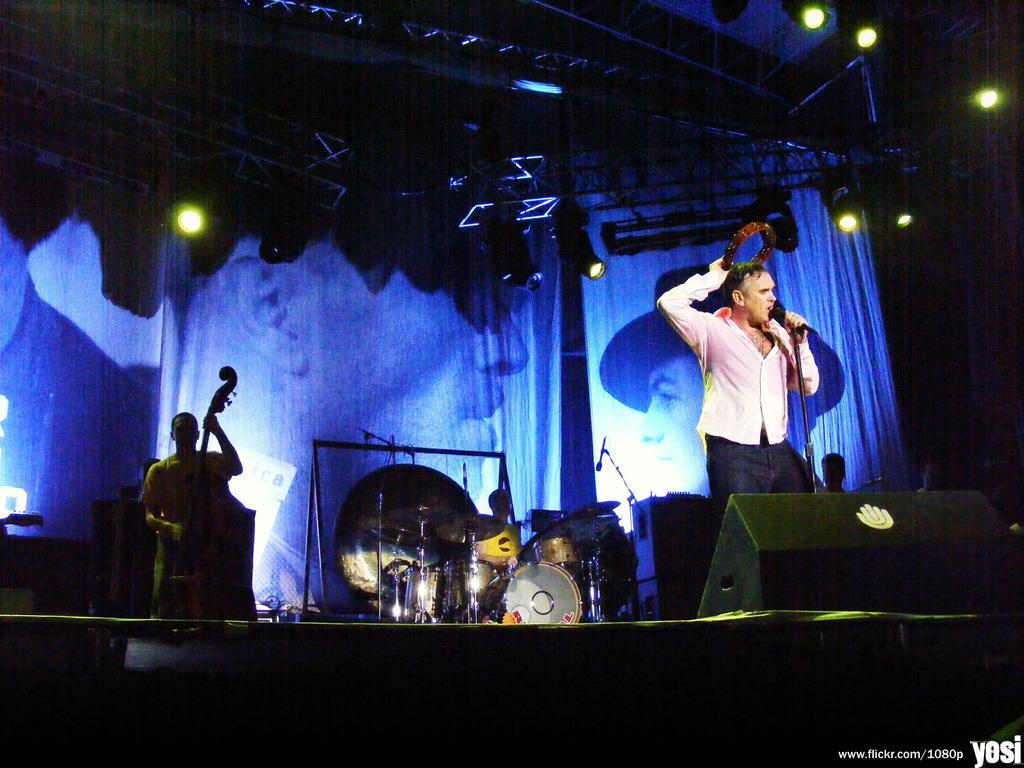Could you give a brief overview of what you see in this image? In this picture we can see a man is standing and holding an object and on the other hand he is holding a microphone with stand. Behind the man there are two people sitting and some musical instruments. Behind the people there are curtains and at the top there are lights. On the image there is a watermark. 